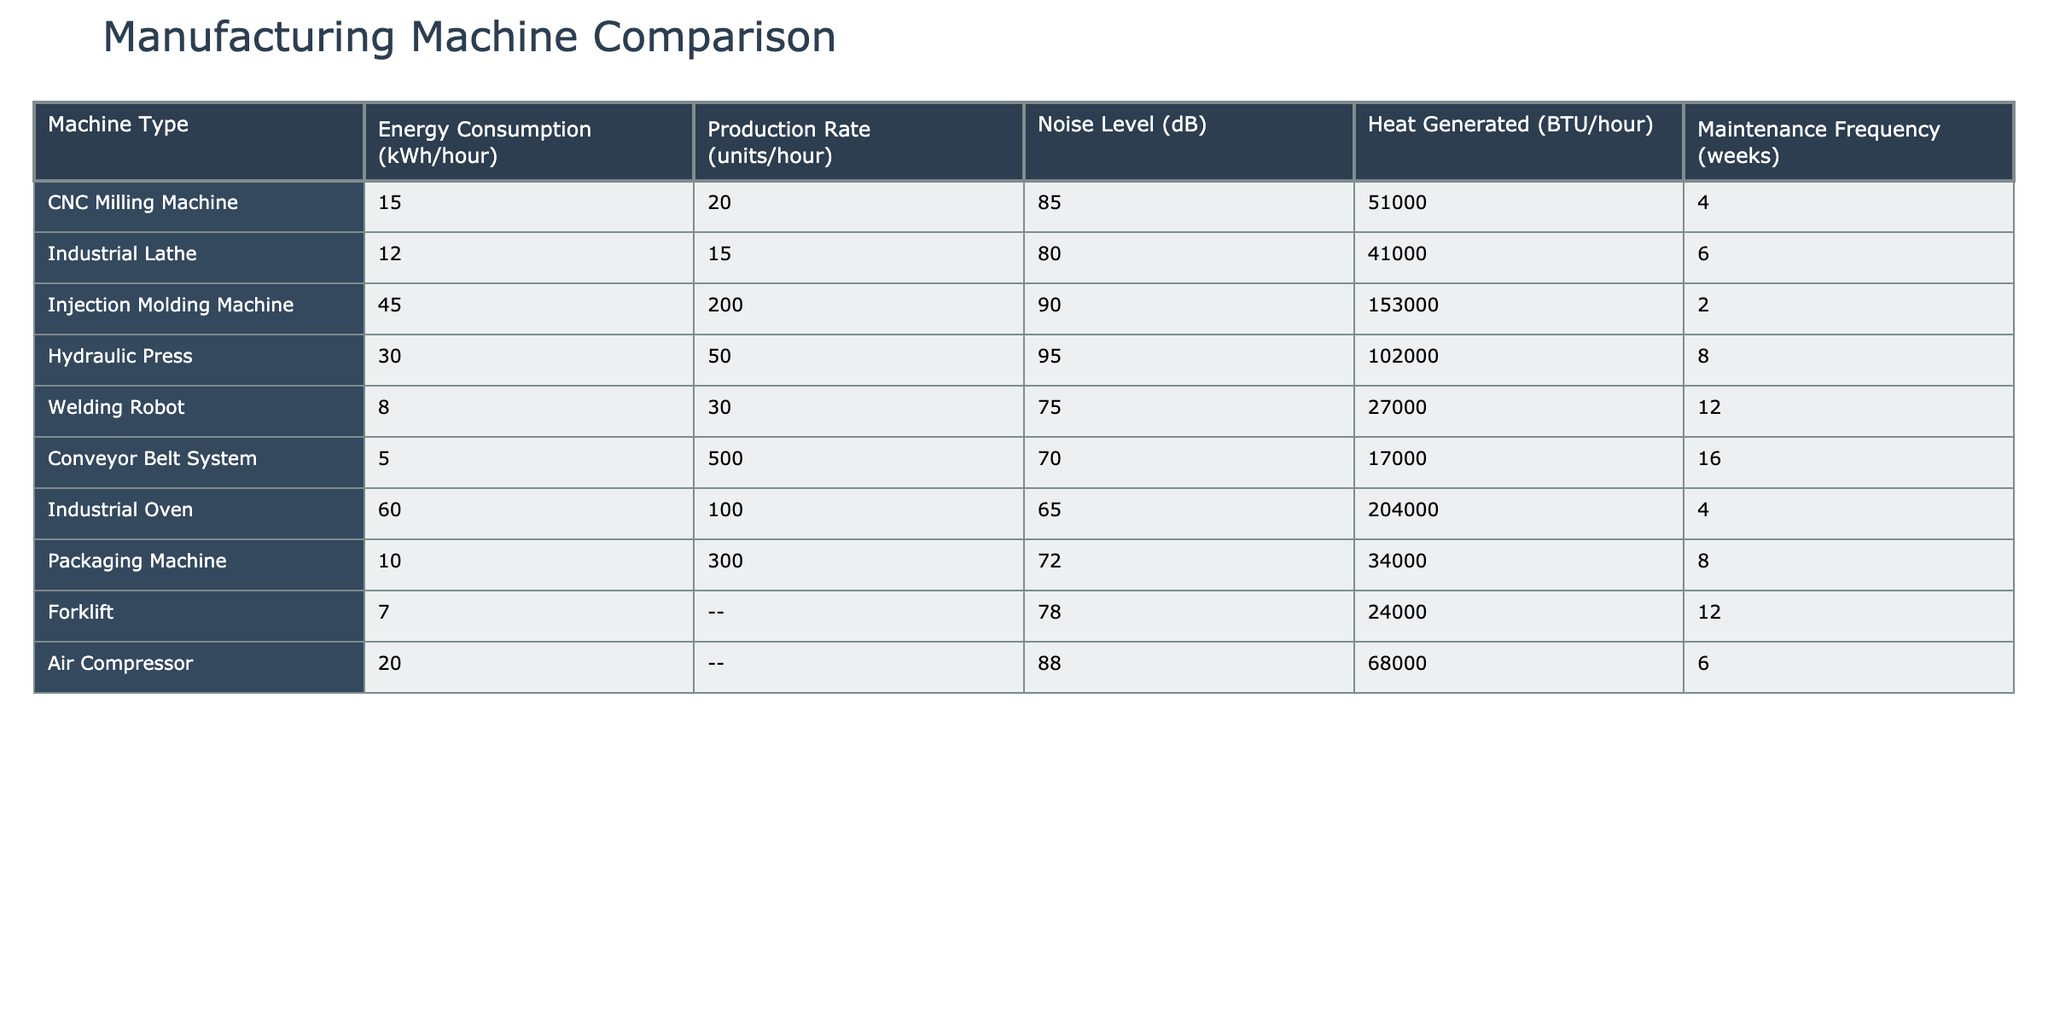What is the energy consumption of the Injection Molding Machine? The table lists the energy consumption for the Injection Molding Machine as 45 kWh/hour.
Answer: 45 kWh/hour Which machine has the highest production rate? According to the table, the machine with the highest production rate is the Conveyor Belt System, producing 500 units/hour.
Answer: Conveyor Belt System Is the noise level of the Hydraulic Press greater than 90 dB? The table shows that the noise level of the Hydraulic Press is 95 dB, which is indeed greater than 90 dB.
Answer: Yes What is the total energy consumption of the CNC Milling Machine and the Industrial Lathe? The CNC Milling Machine consumes 15 kWh/hour and the Industrial Lathe consumes 12 kWh/hour. Adding them gives us a total of 15 + 12 = 27 kWh/hour.
Answer: 27 kWh/hour Which machine generates the most heat? The table indicates that the Industrial Oven generates the most heat at 204,000 BTU/hour.
Answer: Industrial Oven What is the average maintenance frequency of all machines? The sum of maintenance frequencies is (4 + 6 + 2 + 8 + 12 + 16 + 4 + 8 + 12 + 6) = 78 weeks. There are 10 machines, so the average is 78/10 = 7.8 weeks.
Answer: 7.8 weeks Are there more machines with a noise level above 80 dB than below? Machines with a noise level above 80 dB are CNC Milling Machine, Injection Molding Machine, Hydraulic Press, and Air Compressor (4 machines). Machines with a noise level below 80 dB are Welding Robot, Conveyor Belt System, and Packaging Machine (3 machines). Thus, there are more machines above.
Answer: Yes Which machine has the lowest energy consumption? The lowest energy consumption is found in the Conveyor Belt System at 5 kWh/hour, as indicated in the table.
Answer: Conveyor Belt System 